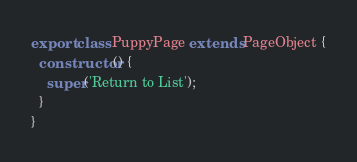Convert code to text. <code><loc_0><loc_0><loc_500><loc_500><_TypeScript_>export class PuppyPage extends PageObject {
  constructor() {
    super('Return to List');
  }
}
</code> 